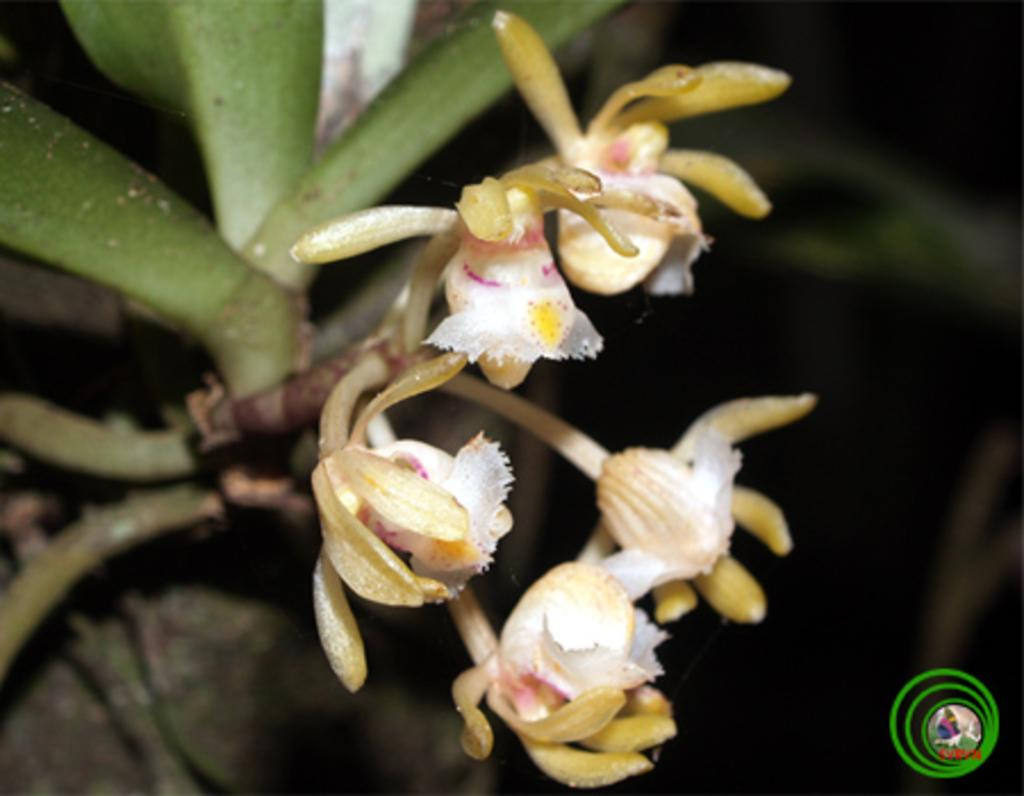What type of living organisms can be seen in the image? There are flowers in the image. What can be seen in the background of the image? There are plants in the background of the image. What type of popcorn can be seen in the image? There is no popcorn present in the image; it features flowers and plants. What type of paper is used to create the flowers in the image? The flowers in the image are not made of paper; they are real living organisms. 